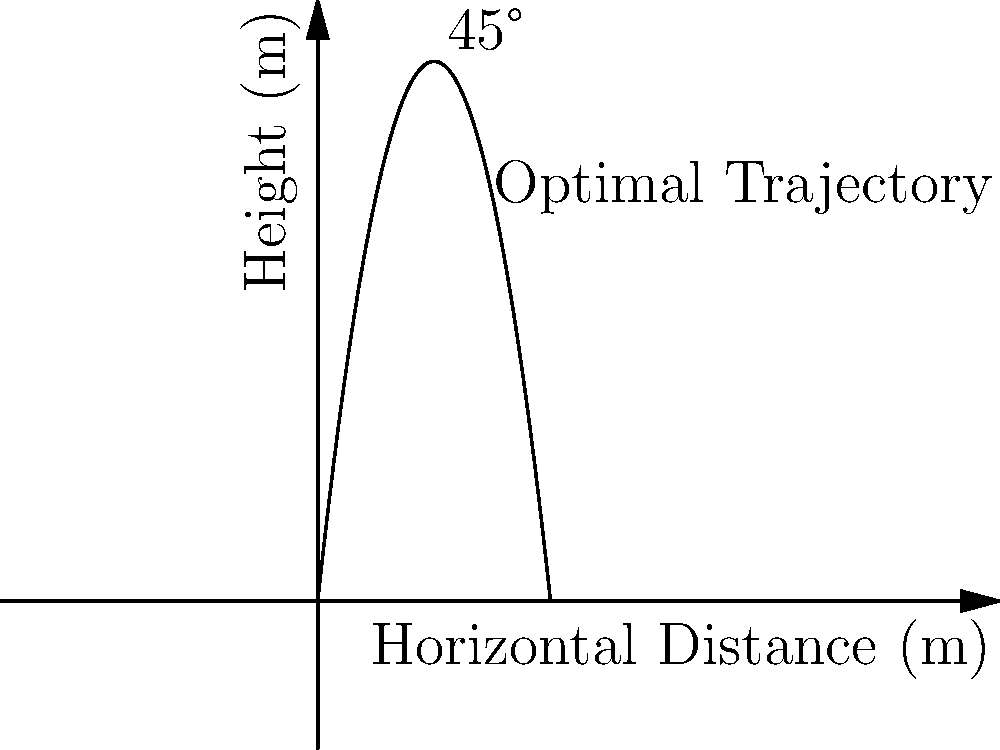As a former gymnastics enthusiast, you're analyzing vault techniques. The graph shows the trajectory of a gymnast's vault. What is the optimal angle for takeoff to maximize horizontal distance, and why does this angle provide the best result? To understand the optimal angle for vault takeoff, let's break down the physics:

1. In projectile motion, the trajectory is determined by initial velocity, angle, and gravity.

2. The horizontal distance (range) is given by the equation:
   $$R = \frac{v^2 \sin(2\theta)}{g}$$
   Where $R$ is range, $v$ is initial velocity, $\theta$ is launch angle, and $g$ is gravitational acceleration.

3. To maximize $R$, we need to maximize $\sin(2\theta)$.

4. The sine function reaches its maximum value of 1 when its argument is 90°.

5. So, $2\theta = 90°$, which means $\theta = 45°$.

6. At 45°, the vertical and horizontal components of velocity are equal, providing the optimal balance between height and forward motion.

7. This 45° angle allows the gymnast to stay in the air for the maximum time while covering the maximum horizontal distance.

8. In practice, air resistance and other factors may slightly alter this angle, but 45° remains the theoretical optimum for an idealized projectile.
Answer: 45° 